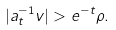<formula> <loc_0><loc_0><loc_500><loc_500>| a _ { t } ^ { - 1 } v | > e ^ { - t } \rho .</formula> 